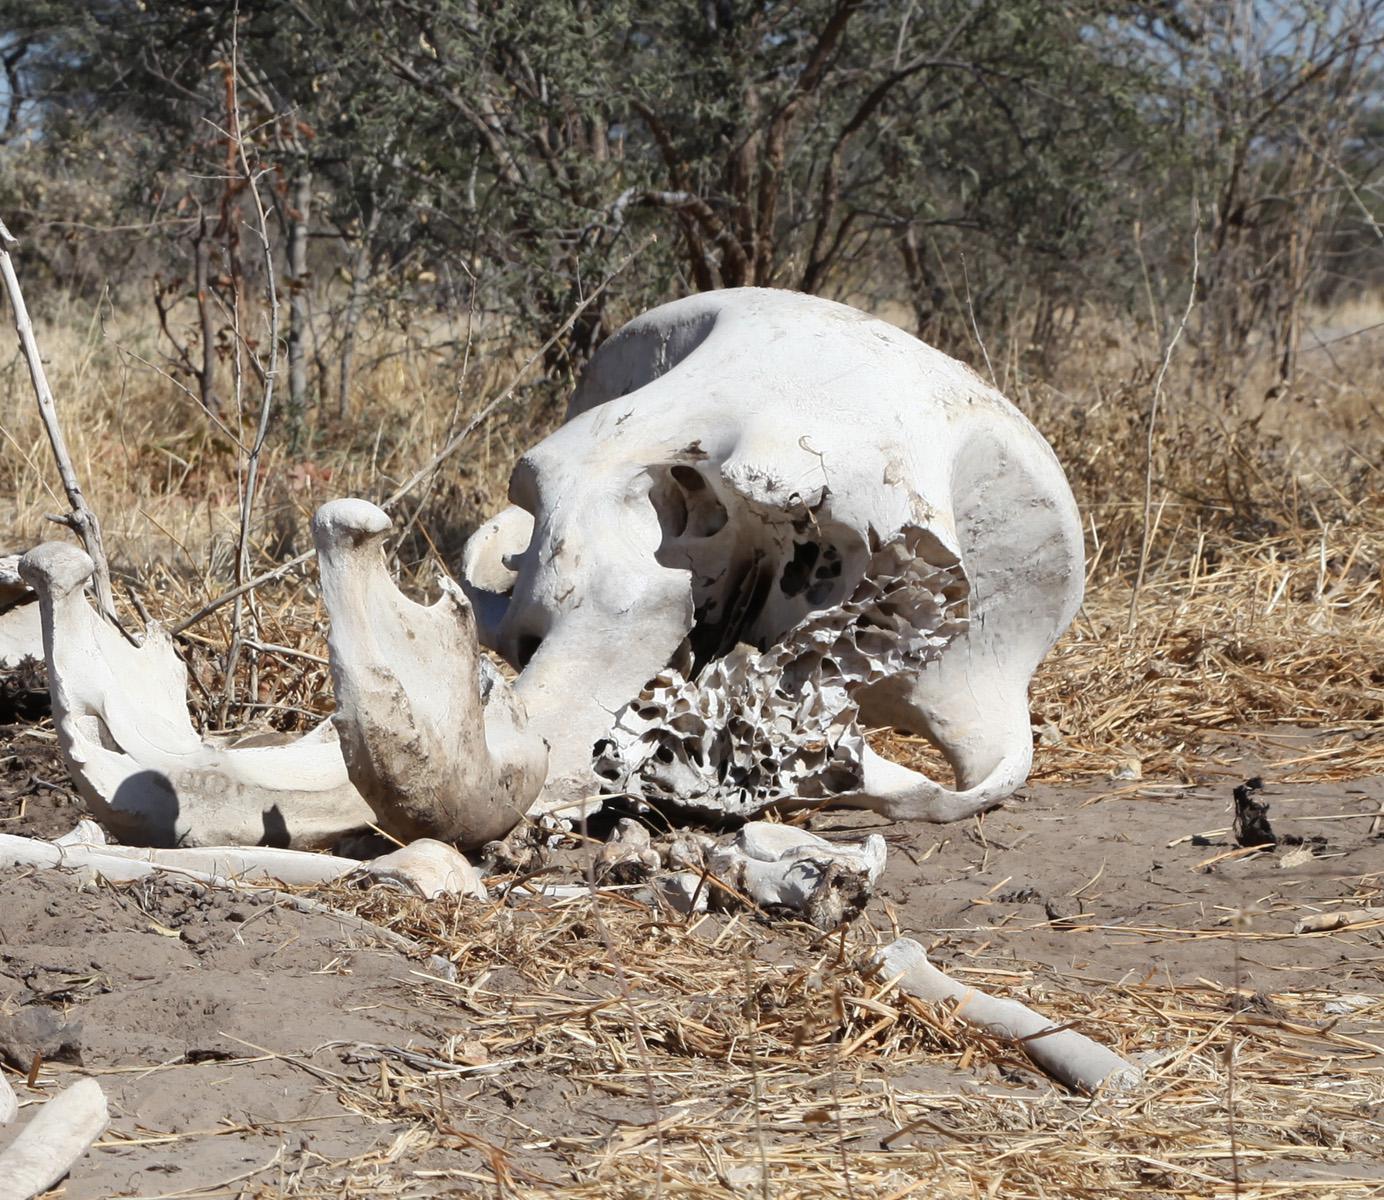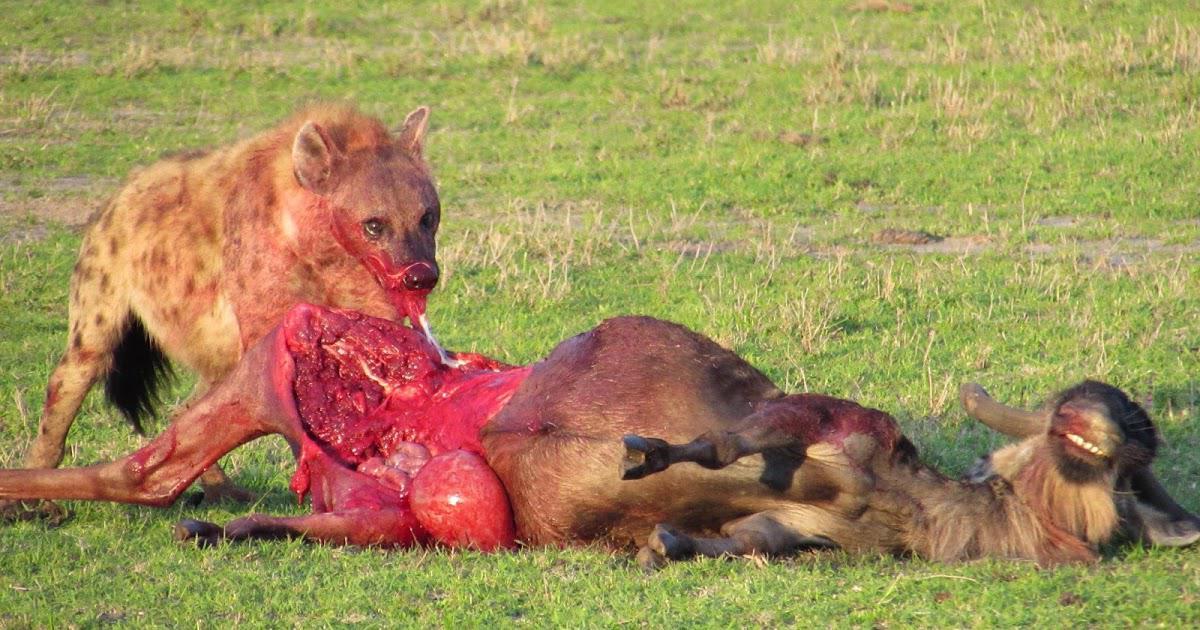The first image is the image on the left, the second image is the image on the right. Examine the images to the left and right. Is the description "The right image contains exactly one hyena." accurate? Answer yes or no. Yes. The first image is the image on the left, the second image is the image on the right. Considering the images on both sides, is "There is at least one hyena in the left image." valid? Answer yes or no. No. 